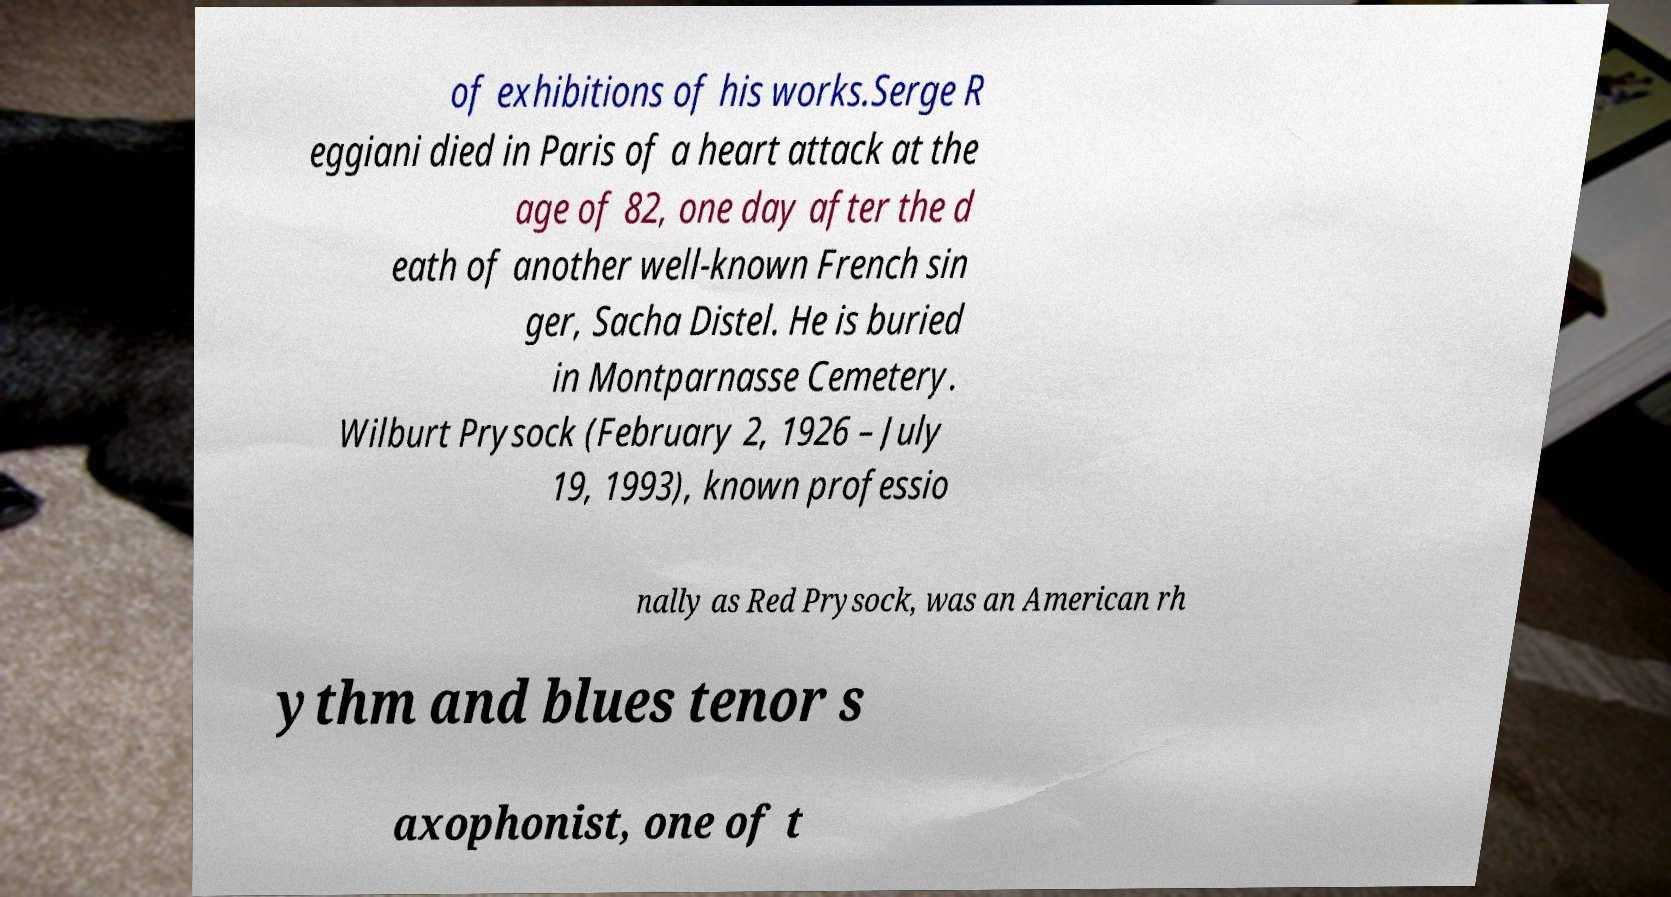What messages or text are displayed in this image? I need them in a readable, typed format. of exhibitions of his works.Serge R eggiani died in Paris of a heart attack at the age of 82, one day after the d eath of another well-known French sin ger, Sacha Distel. He is buried in Montparnasse Cemetery. Wilburt Prysock (February 2, 1926 – July 19, 1993), known professio nally as Red Prysock, was an American rh ythm and blues tenor s axophonist, one of t 